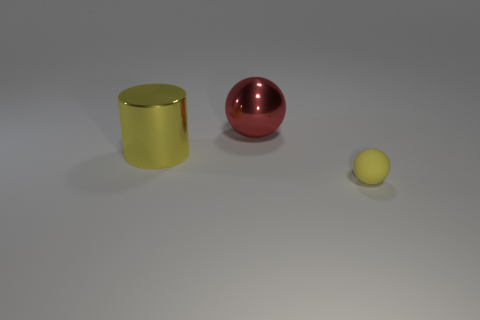Is the shape of the red thing the same as the yellow rubber thing?
Your response must be concise. Yes. What shape is the object on the right side of the sphere behind the small yellow thing?
Your answer should be compact. Sphere. Is there a small yellow shiny block?
Give a very brief answer. No. How many shiny objects are on the right side of the yellow object that is behind the yellow object in front of the large yellow cylinder?
Your answer should be very brief. 1. Do the rubber object and the yellow thing to the left of the large red ball have the same shape?
Offer a very short reply. No. Is the number of tiny yellow spheres greater than the number of large yellow spheres?
Provide a succinct answer. Yes. Are there any other things that are the same size as the yellow matte thing?
Offer a very short reply. No. There is a object right of the red shiny thing; does it have the same shape as the red metallic thing?
Keep it short and to the point. Yes. Are there more small yellow rubber things that are to the right of the large yellow cylinder than tiny purple metallic objects?
Ensure brevity in your answer.  Yes. What color is the thing that is on the right side of the sphere to the left of the yellow ball?
Make the answer very short. Yellow. 